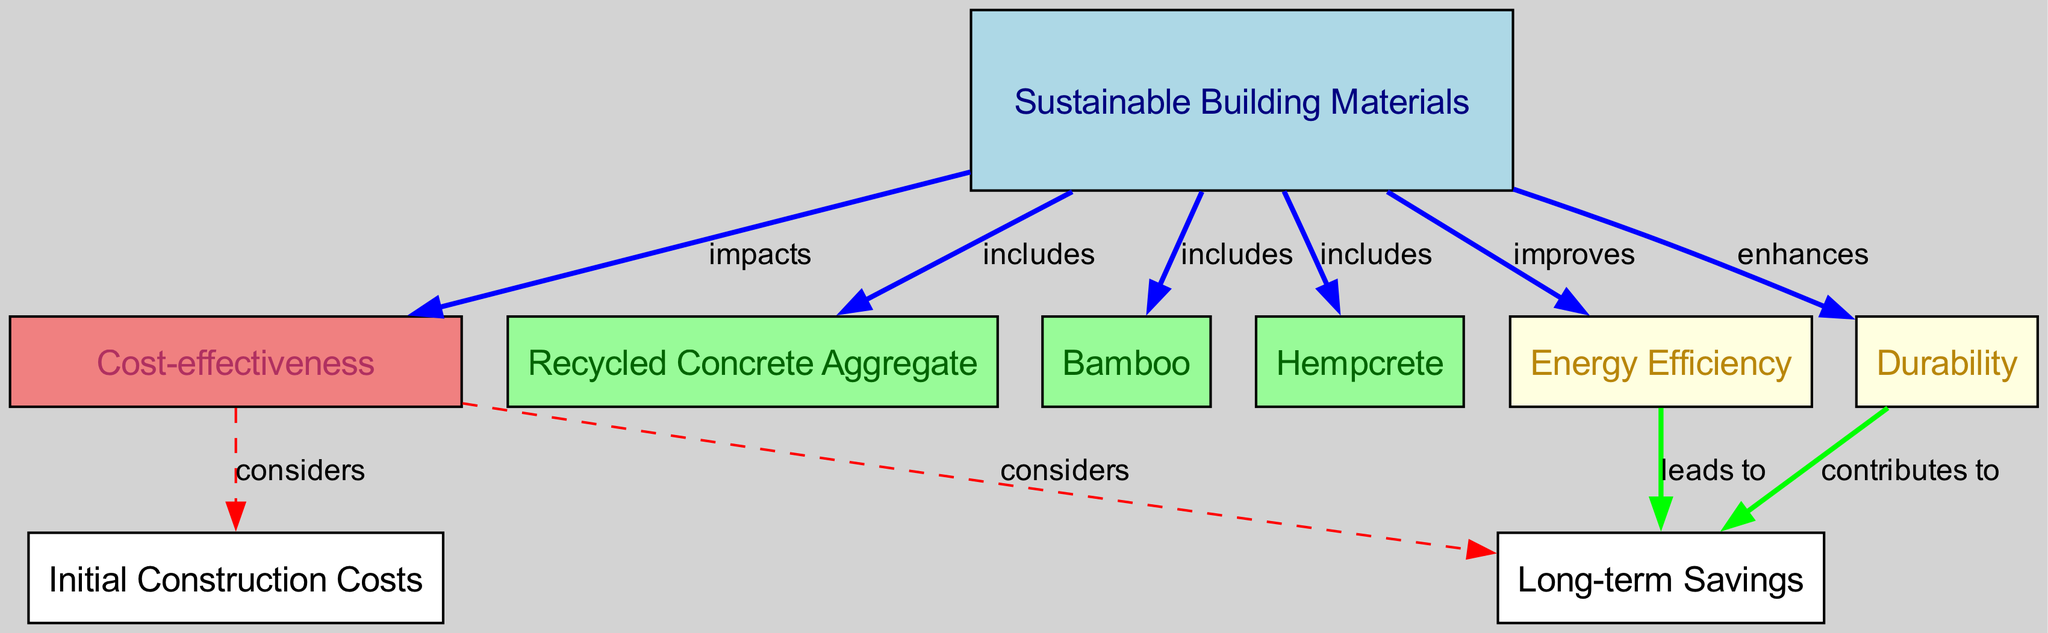What are the components of sustainable building materials? The diagram indicates that sustainable building materials include Recycled Concrete Aggregate, Bamboo, and Hempcrete. Each of these is represented as a node connected to the Sustainable Building Materials node by the label "includes."
Answer: Recycled Concrete Aggregate, Bamboo, Hempcrete What does sustainable building materials impact? According to the diagram, sustainable building materials impact cost-effectiveness, as indicated by the arrow labeled "impacts" connecting Sustainable Building Materials to Cost-effectiveness.
Answer: Cost-effectiveness What two factors does cost-effectiveness consider? The diagram shows that cost-effectiveness considers initial construction costs and long-term savings, represented as two nodes connected to the Cost-effectiveness node by the label "considers."
Answer: Initial construction costs, Long-term savings Which sustainable building material improves energy efficiency? The diagram explicitly shows that sustainable building materials improve energy efficiency, suggesting a direct connection. However, no specific sustainable material is mentioned; it's a general impact of all sustainable materials.
Answer: Sustainable Building Materials How does energy efficiency relate to long-term savings? The relationship in the diagram indicates that energy efficiency leads to long-term savings. There is a directed edge labeled "leads to" from Energy Efficiency to Long-term Savings, indicating a causal connection.
Answer: Leads to How many nodes are there in the diagram? By counting the listed nodes in the diagram, we find there are a total of 9 nodes, each representing a concept related to sustainable building materials and their impacts.
Answer: 9 What enhances long-term savings besides energy efficiency? The diagram indicates that durability contributes to long-term savings. This is shown by the arrow labeled "contributes to" linking Durability to Long-term Savings, showing that it plays a role in achieving cost-effectiveness.
Answer: Durability Which sustainable material is NOT included in the concept of sustainable building materials? The diagram clearly lists Recycled Concrete Aggregate, Bamboo, and Hempcrete as included materials, implying any other material mentioned elsewhere is not part of this specific concept.
Answer: Any material not listed What role does durable construction have in cost-effectiveness? Based on the diagram, durability contributes to long-term savings, and as cost-effectiveness considers long-term savings, we can infer that durable construction positively impacts cost-effectiveness through reduced later expenditures.
Answer: Contributes to cost-effectiveness 